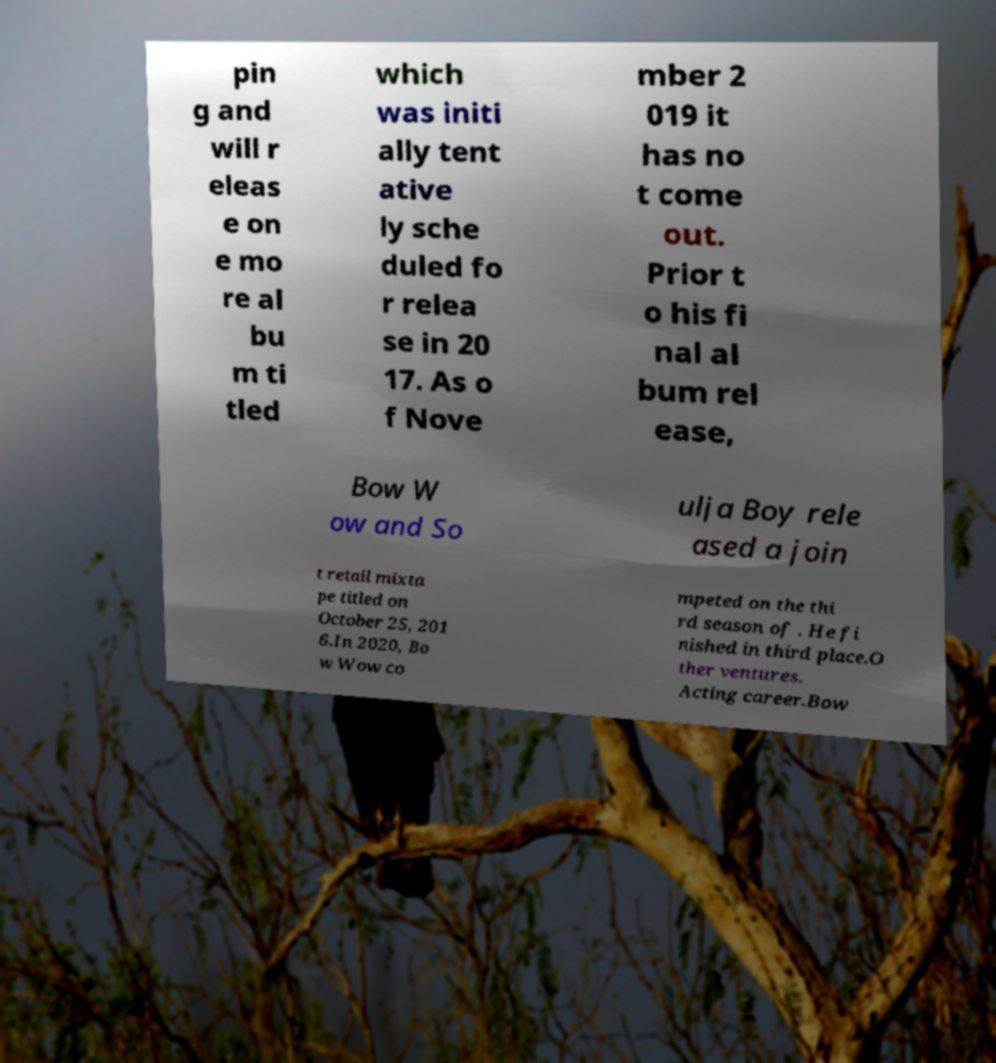Please identify and transcribe the text found in this image. pin g and will r eleas e on e mo re al bu m ti tled which was initi ally tent ative ly sche duled fo r relea se in 20 17. As o f Nove mber 2 019 it has no t come out. Prior t o his fi nal al bum rel ease, Bow W ow and So ulja Boy rele ased a join t retail mixta pe titled on October 25, 201 6.In 2020, Bo w Wow co mpeted on the thi rd season of . He fi nished in third place.O ther ventures. Acting career.Bow 